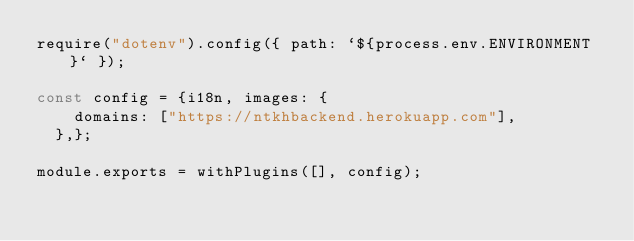Convert code to text. <code><loc_0><loc_0><loc_500><loc_500><_JavaScript_>require("dotenv").config({ path: `${process.env.ENVIRONMENT}` });

const config = {i18n, images: {
    domains: ["https://ntkhbackend.herokuapp.com"],
  },};

module.exports = withPlugins([], config);
</code> 